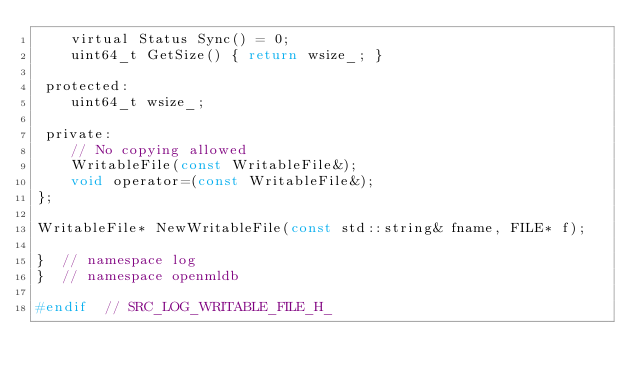<code> <loc_0><loc_0><loc_500><loc_500><_C_>    virtual Status Sync() = 0;
    uint64_t GetSize() { return wsize_; }

 protected:
    uint64_t wsize_;

 private:
    // No copying allowed
    WritableFile(const WritableFile&);
    void operator=(const WritableFile&);
};

WritableFile* NewWritableFile(const std::string& fname, FILE* f);

}  // namespace log
}  // namespace openmldb

#endif  // SRC_LOG_WRITABLE_FILE_H_
</code> 